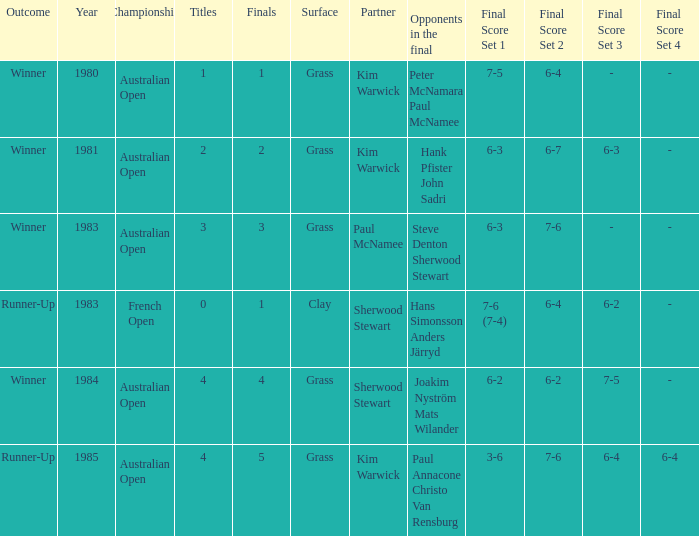What championship was played in 1981? Australian Open (2/2). 